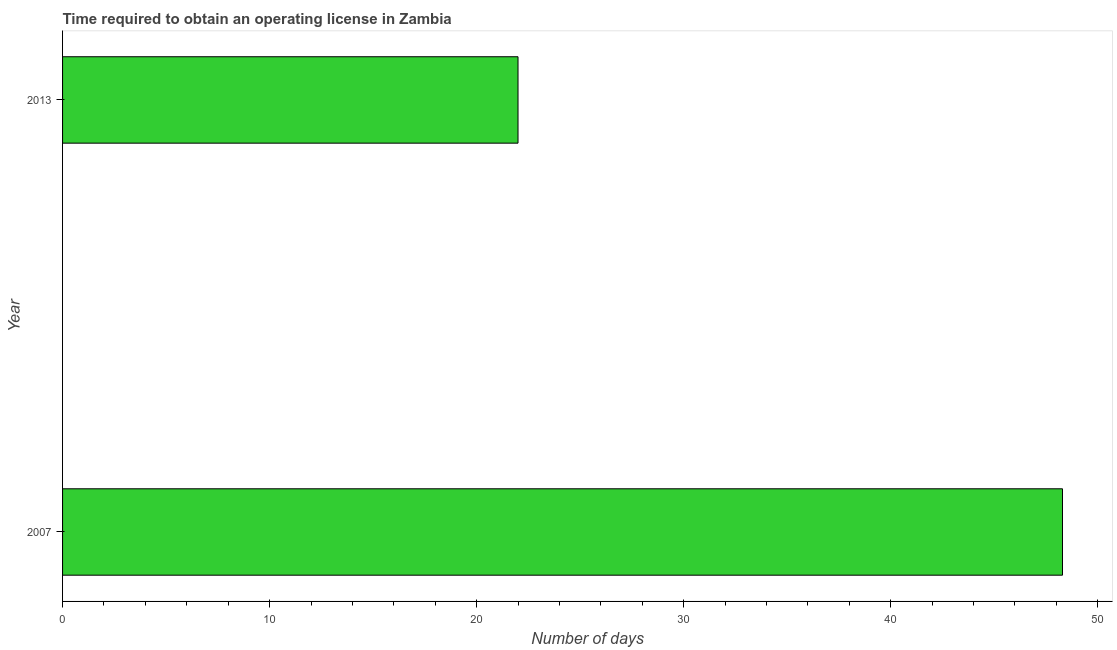Does the graph contain any zero values?
Your answer should be very brief. No. Does the graph contain grids?
Make the answer very short. No. What is the title of the graph?
Offer a terse response. Time required to obtain an operating license in Zambia. What is the label or title of the X-axis?
Your response must be concise. Number of days. What is the label or title of the Y-axis?
Provide a succinct answer. Year. What is the number of days to obtain operating license in 2013?
Make the answer very short. 22. Across all years, what is the maximum number of days to obtain operating license?
Offer a terse response. 48.3. In which year was the number of days to obtain operating license maximum?
Offer a terse response. 2007. What is the sum of the number of days to obtain operating license?
Your answer should be compact. 70.3. What is the difference between the number of days to obtain operating license in 2007 and 2013?
Offer a very short reply. 26.3. What is the average number of days to obtain operating license per year?
Make the answer very short. 35.15. What is the median number of days to obtain operating license?
Ensure brevity in your answer.  35.15. In how many years, is the number of days to obtain operating license greater than 6 days?
Provide a succinct answer. 2. What is the ratio of the number of days to obtain operating license in 2007 to that in 2013?
Your response must be concise. 2.19. In how many years, is the number of days to obtain operating license greater than the average number of days to obtain operating license taken over all years?
Offer a very short reply. 1. How many bars are there?
Your response must be concise. 2. How many years are there in the graph?
Offer a terse response. 2. What is the Number of days of 2007?
Offer a very short reply. 48.3. What is the Number of days in 2013?
Make the answer very short. 22. What is the difference between the Number of days in 2007 and 2013?
Give a very brief answer. 26.3. What is the ratio of the Number of days in 2007 to that in 2013?
Make the answer very short. 2.19. 